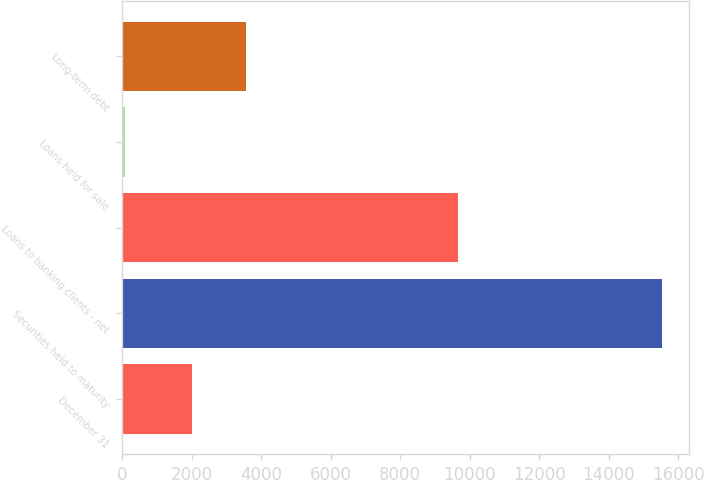Convert chart. <chart><loc_0><loc_0><loc_500><loc_500><bar_chart><fcel>December 31<fcel>Securities held to maturity<fcel>Loans to banking clients - net<fcel>Loans held for sale<fcel>Long-term debt<nl><fcel>2011<fcel>15539<fcel>9671<fcel>73<fcel>3557.6<nl></chart> 